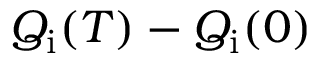<formula> <loc_0><loc_0><loc_500><loc_500>Q _ { i } ( T ) - Q _ { i } ( 0 )</formula> 